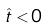Convert formula to latex. <formula><loc_0><loc_0><loc_500><loc_500>\hat { t } < 0</formula> 